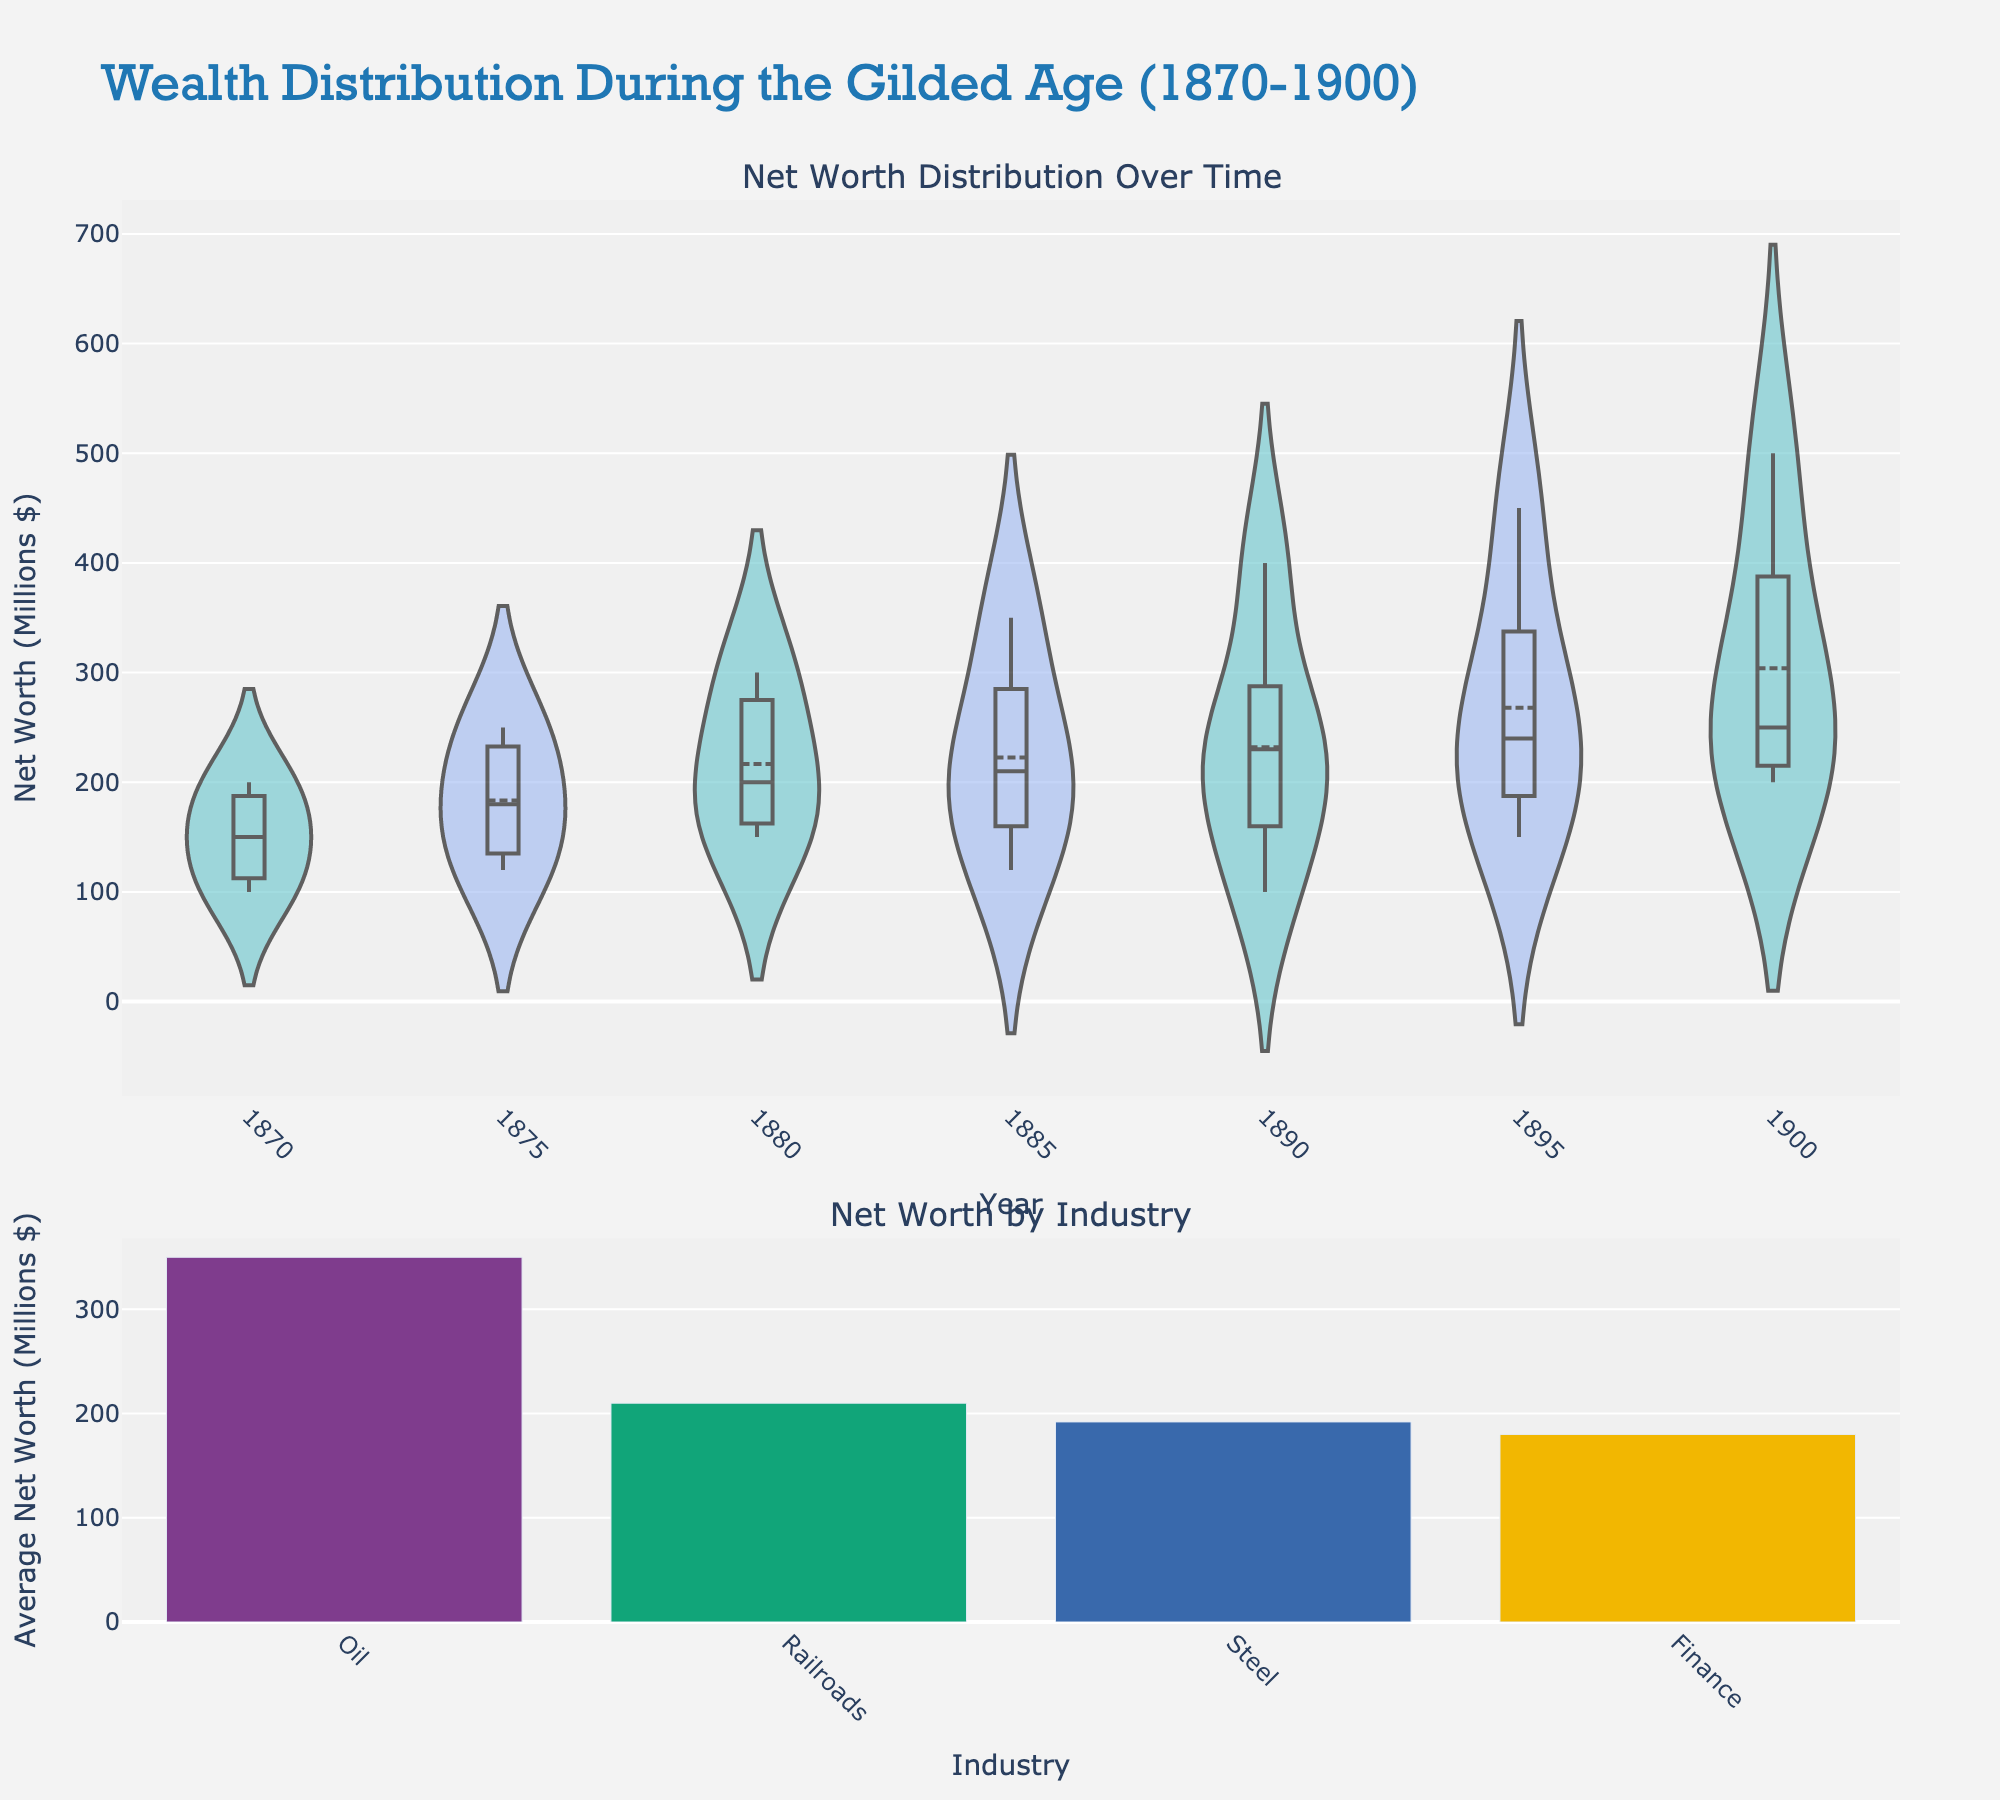What is the title of the figure? The title is printed at the top of the figure. The title reads "Wealth Distribution During the Gilded Age (1870-1900)".
Answer: Wealth Distribution During the Gilded Age (1870-1900) Which year had the highest distribution of net worth in the violin plot? The violin plot shows the distribution of net worth by year. The year with the widest and highest distribution indicates the highest net worth.
Answer: 1900 Which industry had the highest average net worth according to the bar plot? The bar plot at the bottom shows the average net worth by industry. The tallest bar represents the industry with the highest average net worth.
Answer: Oil What was John D. Rockefeller's net worth in 1900? The violin plot on the top provides net worth values over time segmented by individuals. Based on the name and color associated with each person, Rockefeller’s net worth can be extracted for the year 1900.
Answer: 500 million dollars How did Cornelius Vanderbilt's net worth change from 1870 to 1900? To determine the change in net worth, compare Vanderbilt's values from the violin plots at 1870 and 1900. Look for the year labels and respective net worth entries.
Answer: Increased from 150 million dollars to 250 million dollars Which individual had the most consistent net worth increase over the years? Observe the violin plot lines over different years. The consistency and linearity of the increase indicate the individual with the most consistent net worth rise.
Answer: John D. Rockefeller What is the net worth difference between Andrew Carnegie and Henry Clay Frick in 1900? Look at the individual values on the violin plot for the year 1900, identify Carnegie and Frick's net worth, and calculate the difference.
Answer: 150 million dollars Which industry shows the second highest average net worth in the bar plot? Examine the heights of the bars in the bar plot and identify the one that is the second tallest.
Answer: Steel Between 1885 and 1890, which industrial magnate experienced the biggest net worth gain? Compare individual net worth values from the violin plot for 1885 and 1890, and determine who had the highest increase.
Answer: Andrew Carnegie How does the distribution of net worth change from 1870 to 1900? Analyze the overall spread and shape of the violin plots from both years. Wider and higher distributions indicate a greater variance and higher net worth levels.
Answer: The distribution becomes wider and higher, indicating increased wealth and greater disparities 